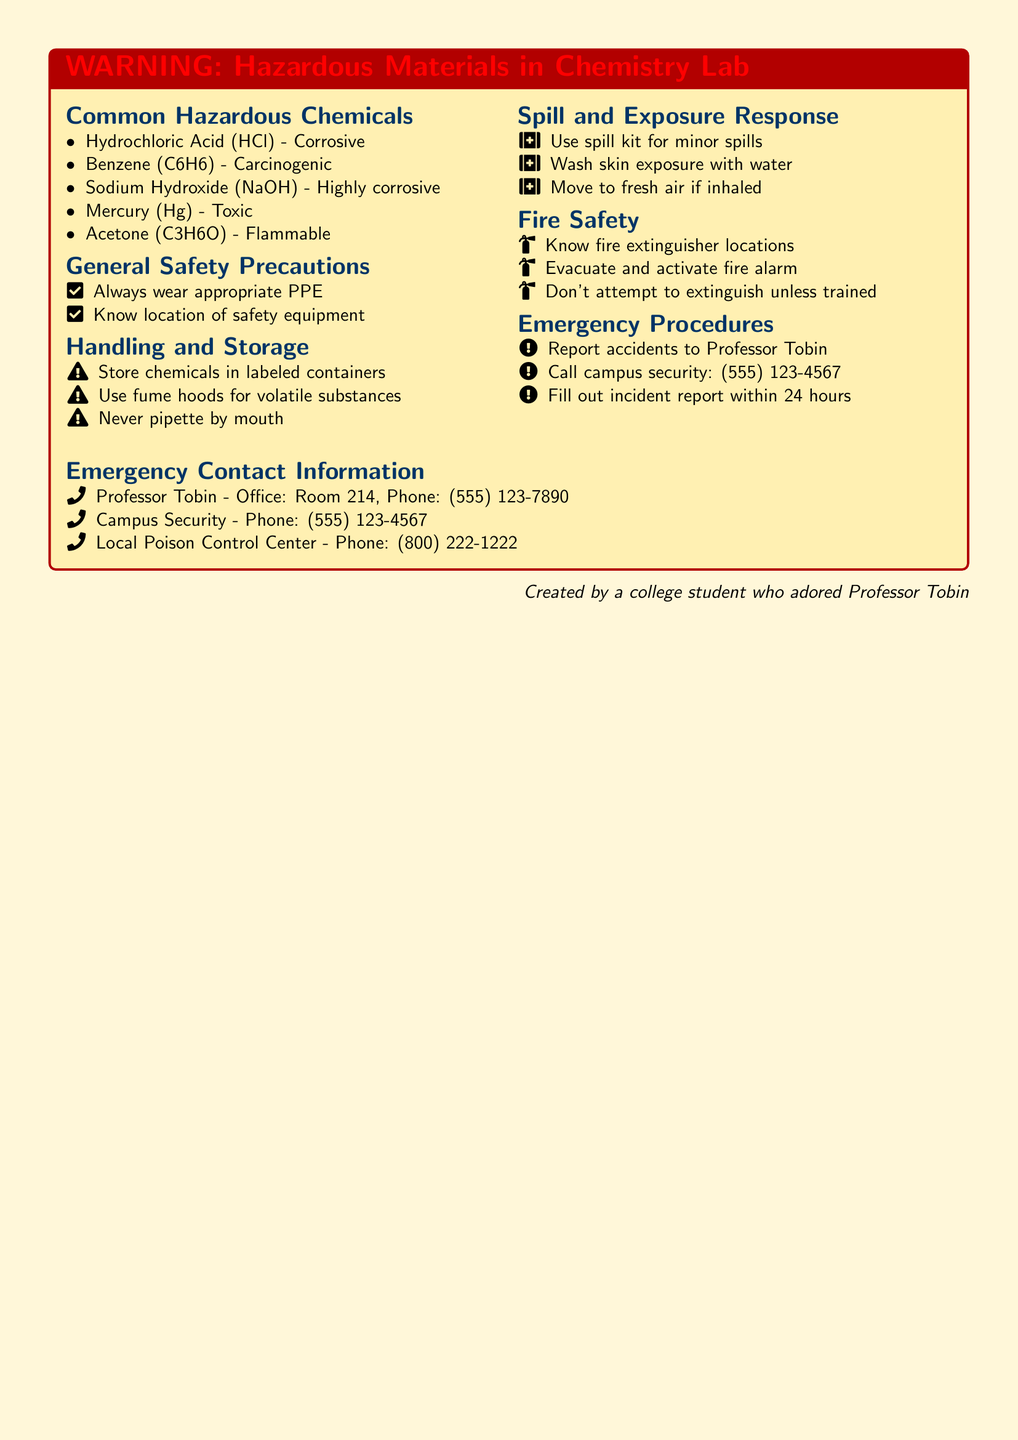What is the title of the document? The title of the document is the heading displayed prominently at the top of the warning box.
Answer: WARNING: Hazardous Materials in Chemistry Lab What is one hazardous chemical listed in the document? The document provides a list of common hazardous chemicals within the Chemistry Lab section.
Answer: Hydrochloric Acid Where should chemicals be stored according to the safety precautions? The handling and storage section specifies where to keep chemicals for safety.
Answer: Labeled containers What should you do in case of skin exposure to hazardous materials? The spill and exposure response section outlines appropriate actions for various scenarios.
Answer: Wash skin exposure with water Who should accidents be reported to? The emergency procedures specify the person to report accidents to for further action.
Answer: Professor Tobin What is the phone number for campus security? The emergency contact information includes important contact numbers in case of incidents.
Answer: (555) 123-4567 What should not be attempted unless trained? The fire safety section mentions actions that require training for safety.
Answer: Extinguish fires Which chemical is classified as carcinogenic? The document specifies a hazardous chemical that is known to cause cancer.
Answer: Benzene What should be done within 24 hours after an incident? The emergency procedures list the protocol to follow after an accident has occurred.
Answer: Fill out incident report 